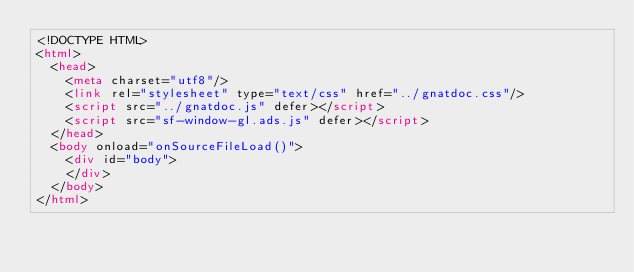Convert code to text. <code><loc_0><loc_0><loc_500><loc_500><_HTML_><!DOCTYPE HTML>
<html>
  <head>
    <meta charset="utf8"/>
    <link rel="stylesheet" type="text/css" href="../gnatdoc.css"/>
    <script src="../gnatdoc.js" defer></script>
    <script src="sf-window-gl.ads.js" defer></script>
  </head>
  <body onload="onSourceFileLoad()">
    <div id="body">
    </div>
  </body>
</html></code> 